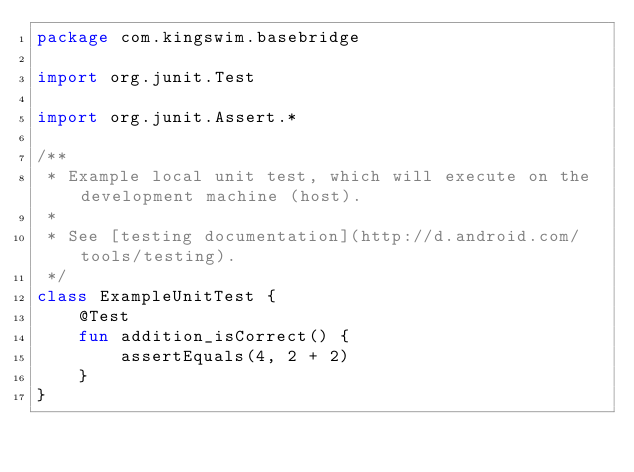<code> <loc_0><loc_0><loc_500><loc_500><_Kotlin_>package com.kingswim.basebridge

import org.junit.Test

import org.junit.Assert.*

/**
 * Example local unit test, which will execute on the development machine (host).
 *
 * See [testing documentation](http://d.android.com/tools/testing).
 */
class ExampleUnitTest {
    @Test
    fun addition_isCorrect() {
        assertEquals(4, 2 + 2)
    }
}</code> 